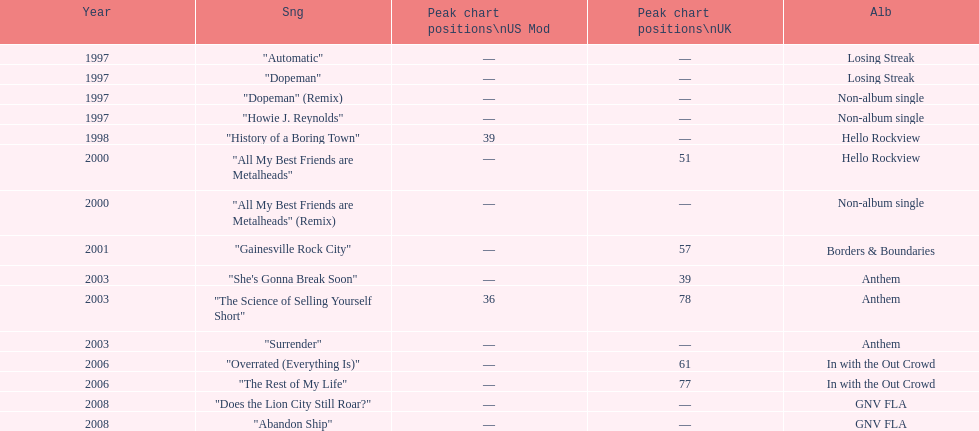Which year has the most singles? 1997. Would you be able to parse every entry in this table? {'header': ['Year', 'Sng', 'Peak chart positions\\nUS Mod', 'Peak chart positions\\nUK', 'Alb'], 'rows': [['1997', '"Automatic"', '—', '—', 'Losing Streak'], ['1997', '"Dopeman"', '—', '—', 'Losing Streak'], ['1997', '"Dopeman" (Remix)', '—', '—', 'Non-album single'], ['1997', '"Howie J. Reynolds"', '—', '—', 'Non-album single'], ['1998', '"History of a Boring Town"', '39', '—', 'Hello Rockview'], ['2000', '"All My Best Friends are Metalheads"', '—', '51', 'Hello Rockview'], ['2000', '"All My Best Friends are Metalheads" (Remix)', '—', '—', 'Non-album single'], ['2001', '"Gainesville Rock City"', '—', '57', 'Borders & Boundaries'], ['2003', '"She\'s Gonna Break Soon"', '—', '39', 'Anthem'], ['2003', '"The Science of Selling Yourself Short"', '36', '78', 'Anthem'], ['2003', '"Surrender"', '—', '—', 'Anthem'], ['2006', '"Overrated (Everything Is)"', '—', '61', 'In with the Out Crowd'], ['2006', '"The Rest of My Life"', '—', '77', 'In with the Out Crowd'], ['2008', '"Does the Lion City Still Roar?"', '—', '—', 'GNV FLA'], ['2008', '"Abandon Ship"', '—', '—', 'GNV FLA']]} 